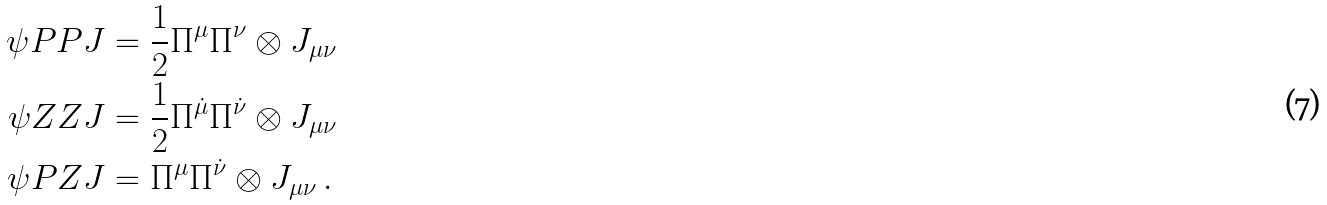Convert formula to latex. <formula><loc_0><loc_0><loc_500><loc_500>\psi P P J & = \frac { 1 } { 2 } \Pi ^ { \mu } \Pi ^ { \nu } \otimes J _ { \mu \nu } \\ \psi Z Z J & = \frac { 1 } { 2 } \Pi ^ { \dot { \mu } } \Pi ^ { \dot { \nu } } \otimes J _ { \mu \nu } \\ \psi P Z J & = \Pi ^ { \mu } \Pi ^ { \dot { \nu } } \otimes J _ { \mu \nu } \, .</formula> 